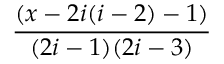Convert formula to latex. <formula><loc_0><loc_0><loc_500><loc_500>\frac { ( x - 2 i ( i - 2 ) - 1 ) } { ( 2 i - 1 ) ( 2 i - 3 ) }</formula> 